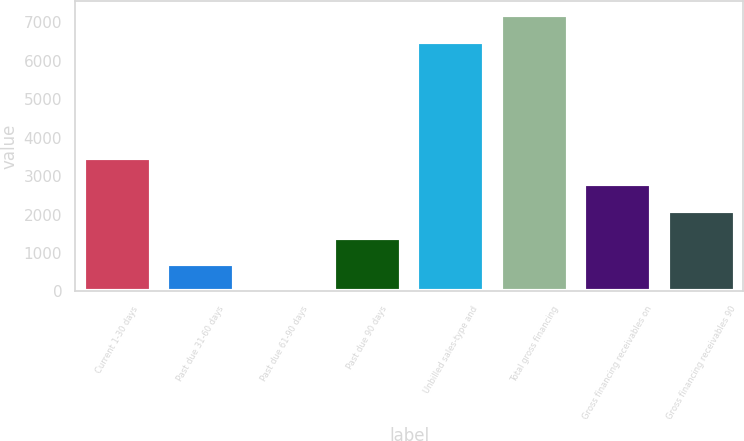<chart> <loc_0><loc_0><loc_500><loc_500><bar_chart><fcel>Current 1-30 days<fcel>Past due 31-60 days<fcel>Past due 61-90 days<fcel>Past due 90 days<fcel>Unbilled sales-type and<fcel>Total gross financing<fcel>Gross financing receivables on<fcel>Gross financing receivables 90<nl><fcel>3481<fcel>705.8<fcel>12<fcel>1399.6<fcel>6495<fcel>7188.8<fcel>2787.2<fcel>2093.4<nl></chart> 